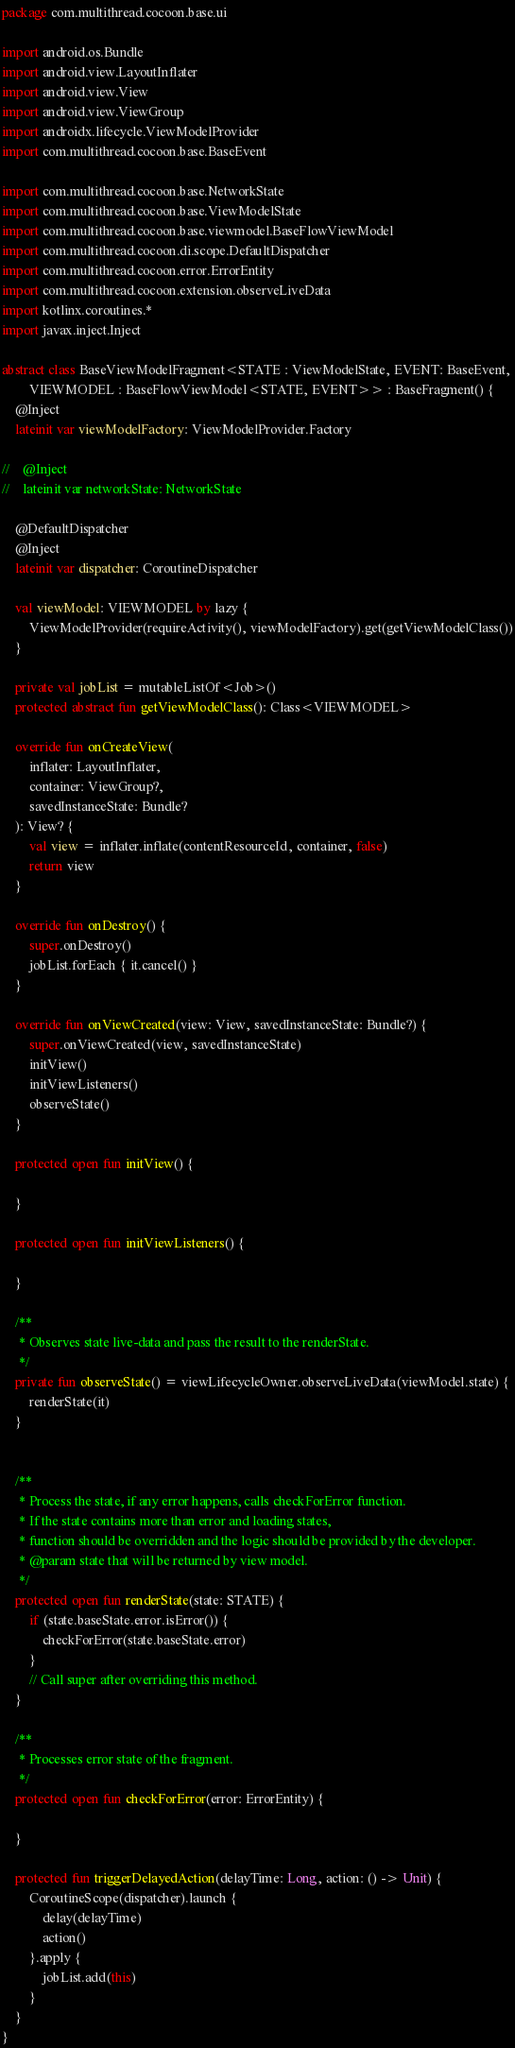<code> <loc_0><loc_0><loc_500><loc_500><_Kotlin_>package com.multithread.cocoon.base.ui

import android.os.Bundle
import android.view.LayoutInflater
import android.view.View
import android.view.ViewGroup
import androidx.lifecycle.ViewModelProvider
import com.multithread.cocoon.base.BaseEvent

import com.multithread.cocoon.base.NetworkState
import com.multithread.cocoon.base.ViewModelState
import com.multithread.cocoon.base.viewmodel.BaseFlowViewModel
import com.multithread.cocoon.di.scope.DefaultDispatcher
import com.multithread.cocoon.error.ErrorEntity
import com.multithread.cocoon.extension.observeLiveData
import kotlinx.coroutines.*
import javax.inject.Inject

abstract class BaseViewModelFragment<STATE : ViewModelState, EVENT: BaseEvent,
        VIEWMODEL : BaseFlowViewModel<STATE, EVENT>> : BaseFragment() {
    @Inject
    lateinit var viewModelFactory: ViewModelProvider.Factory

//    @Inject
//    lateinit var networkState: NetworkState

    @DefaultDispatcher
    @Inject
    lateinit var dispatcher: CoroutineDispatcher

    val viewModel: VIEWMODEL by lazy {
        ViewModelProvider(requireActivity(), viewModelFactory).get(getViewModelClass())
    }

    private val jobList = mutableListOf<Job>()
    protected abstract fun getViewModelClass(): Class<VIEWMODEL>

    override fun onCreateView(
        inflater: LayoutInflater,
        container: ViewGroup?,
        savedInstanceState: Bundle?
    ): View? {
        val view = inflater.inflate(contentResourceId, container, false)
        return view
    }

    override fun onDestroy() {
        super.onDestroy()
        jobList.forEach { it.cancel() }
    }

    override fun onViewCreated(view: View, savedInstanceState: Bundle?) {
        super.onViewCreated(view, savedInstanceState)
        initView()
        initViewListeners()
        observeState()
    }

    protected open fun initView() {

    }

    protected open fun initViewListeners() {

    }

    /**
     * Observes state live-data and pass the result to the renderState.
     */
    private fun observeState() = viewLifecycleOwner.observeLiveData(viewModel.state) {
        renderState(it)
    }


    /**
     * Process the state, if any error happens, calls checkForError function.
     * If the state contains more than error and loading states,
     * function should be overridden and the logic should be provided by the developer.
     * @param state that will be returned by view model.
     */
    protected open fun renderState(state: STATE) {
        if (state.baseState.error.isError()) {
            checkForError(state.baseState.error)
        }
        // Call super after overriding this method.
    }

    /**
     * Processes error state of the fragment.
     */
    protected open fun checkForError(error: ErrorEntity) {

    }

    protected fun triggerDelayedAction(delayTime: Long, action: () -> Unit) {
        CoroutineScope(dispatcher).launch {
            delay(delayTime)
            action()
        }.apply {
            jobList.add(this)
        }
    }
}</code> 